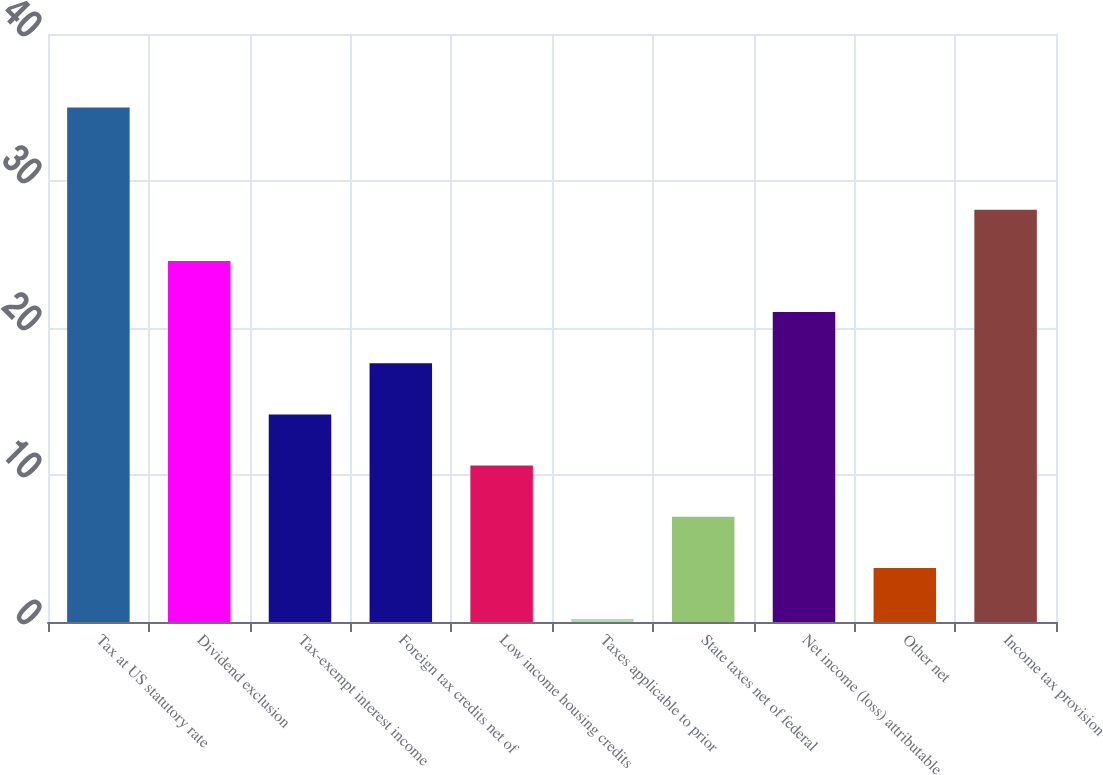Convert chart to OTSL. <chart><loc_0><loc_0><loc_500><loc_500><bar_chart><fcel>Tax at US statutory rate<fcel>Dividend exclusion<fcel>Tax-exempt interest income<fcel>Foreign tax credits net of<fcel>Low income housing credits<fcel>Taxes applicable to prior<fcel>State taxes net of federal<fcel>Net income (loss) attributable<fcel>Other net<fcel>Income tax provision<nl><fcel>35<fcel>24.56<fcel>14.12<fcel>17.6<fcel>10.64<fcel>0.2<fcel>7.16<fcel>21.08<fcel>3.68<fcel>28.04<nl></chart> 